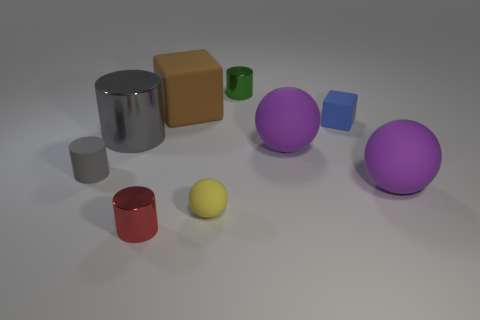Is there any other thing of the same color as the tiny cube?
Your answer should be very brief. No. There is a rubber sphere behind the matte cylinder; is it the same color as the rubber cube in front of the brown block?
Offer a terse response. No. The tiny cylinder that is to the right of the red metallic cylinder is what color?
Make the answer very short. Green. There is a gray cylinder right of the rubber cylinder; is it the same size as the tiny red cylinder?
Give a very brief answer. No. Are there fewer tiny green shiny cylinders than big spheres?
Keep it short and to the point. Yes. There is a metal thing that is the same color as the small rubber cylinder; what is its shape?
Offer a terse response. Cylinder. How many large rubber blocks are behind the blue matte thing?
Give a very brief answer. 1. Is the large brown object the same shape as the yellow rubber object?
Offer a terse response. No. How many metallic cylinders are both behind the rubber cylinder and in front of the brown rubber thing?
Provide a short and direct response. 1. How many objects are small blue metallic cylinders or small green metal things behind the yellow matte thing?
Keep it short and to the point. 1. 